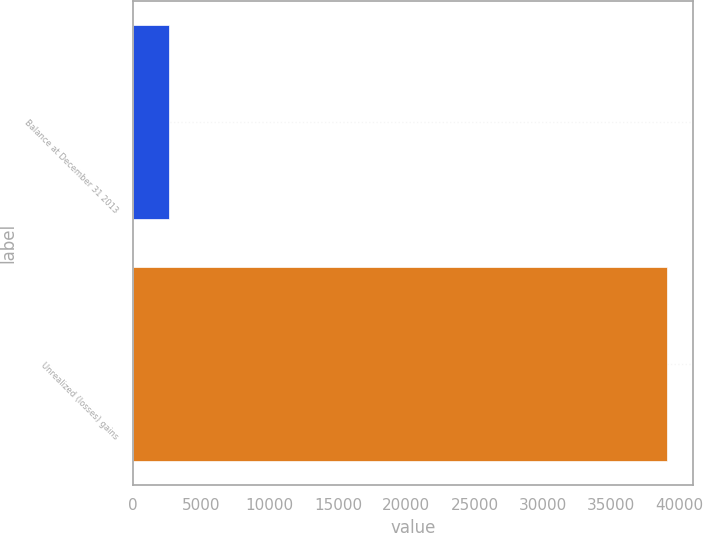Convert chart. <chart><loc_0><loc_0><loc_500><loc_500><bar_chart><fcel>Balance at December 31 2013<fcel>Unrealized (losses) gains<nl><fcel>2645<fcel>39036<nl></chart> 